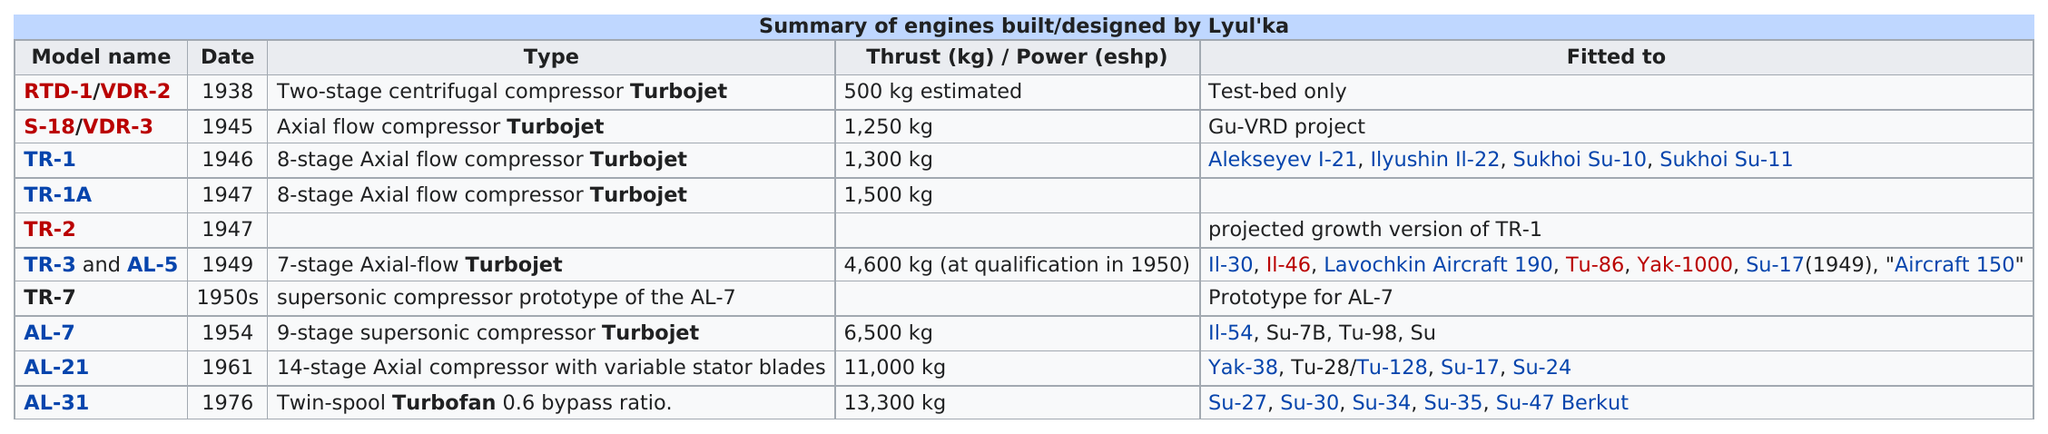Highlight a few significant elements in this photo. Before 1980, the top thrust achieved by a Lyul'ka engine was 13,300 kg. The next models after TR-2 are TR-3 and AL-5. The model that was dated before model S-18/VDR-3 was RTD-1/VDR-2. What model is listed first in the table? It is the RTD-1/VDR-2. The Al-7 and Al-21 have a difference in thrust of approximately 4,500 kg. 